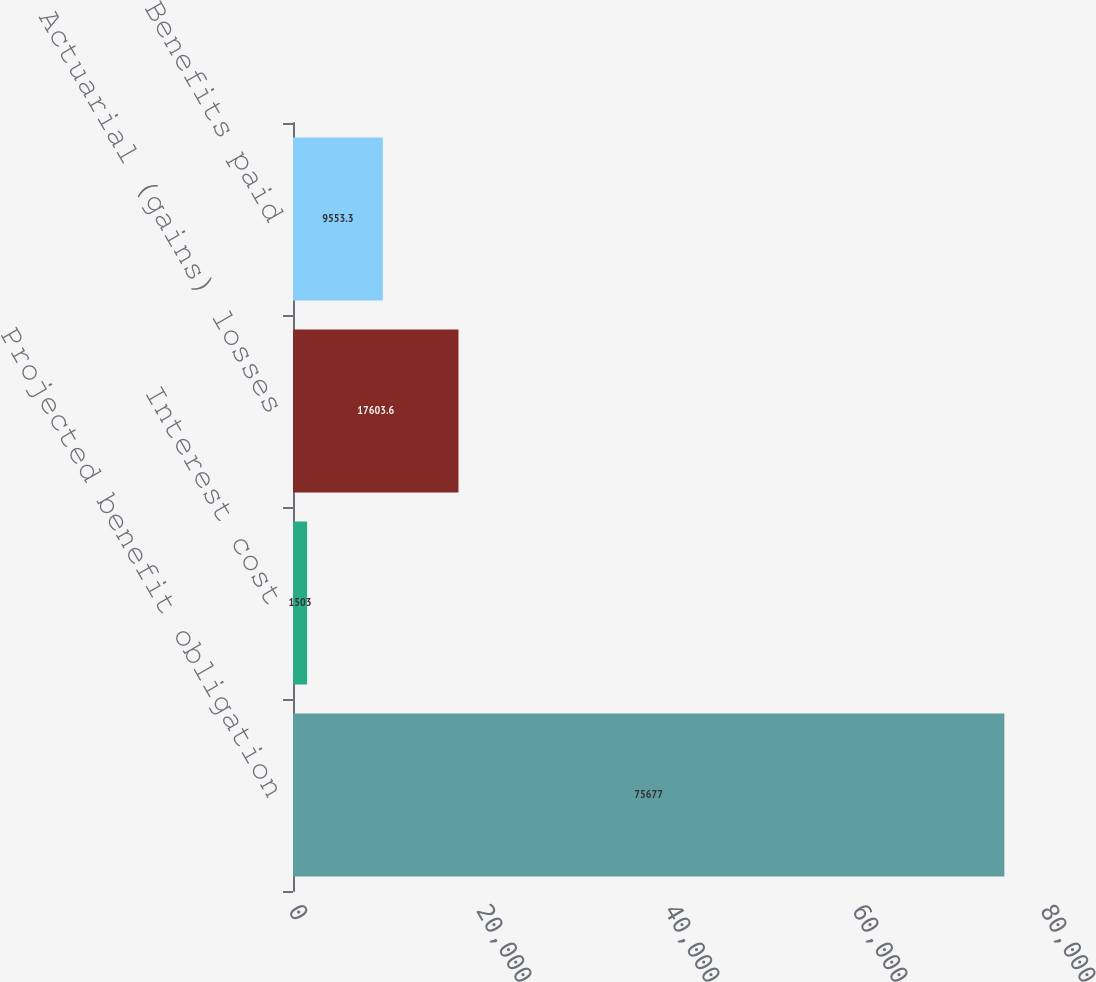<chart> <loc_0><loc_0><loc_500><loc_500><bar_chart><fcel>Projected benefit obligation<fcel>Interest cost<fcel>Actuarial (gains) losses<fcel>Benefits paid<nl><fcel>75677<fcel>1503<fcel>17603.6<fcel>9553.3<nl></chart> 